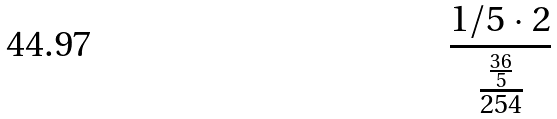Convert formula to latex. <formula><loc_0><loc_0><loc_500><loc_500>\frac { 1 / 5 \cdot 2 } { \frac { \frac { 3 6 } { 5 } } { 2 5 4 } }</formula> 